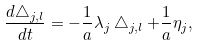<formula> <loc_0><loc_0><loc_500><loc_500>\frac { d \bigtriangleup _ { j , l } } { d t } = - \frac { 1 } { a } \lambda _ { j } \bigtriangleup _ { j , l } + \frac { 1 } { a } \eta _ { j } ,</formula> 